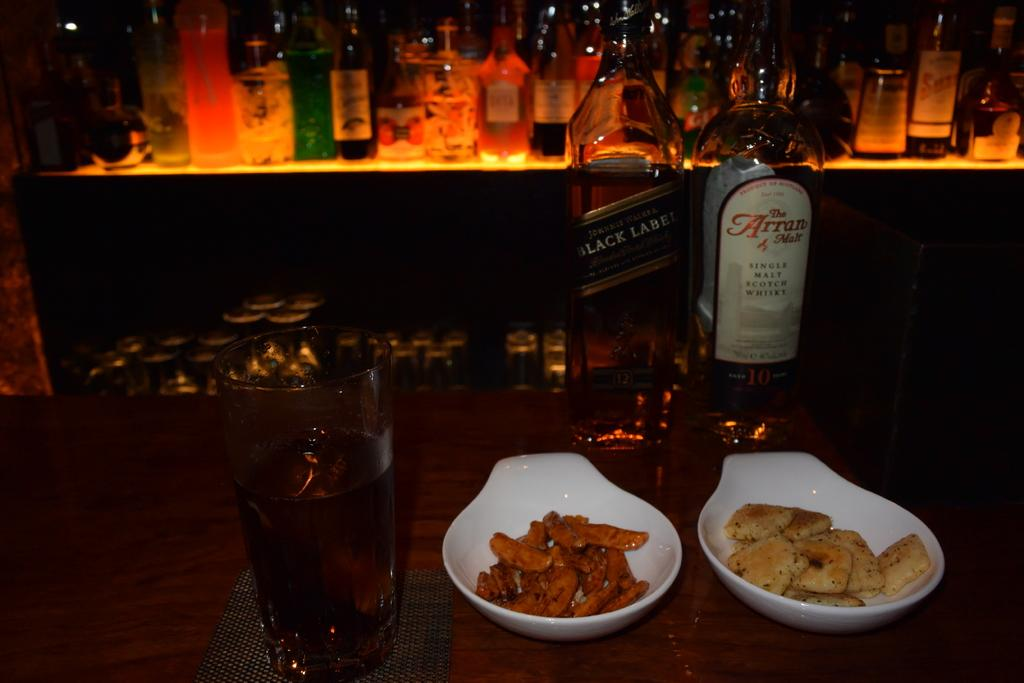<image>
Provide a brief description of the given image. the word single that is on a wine bottle 